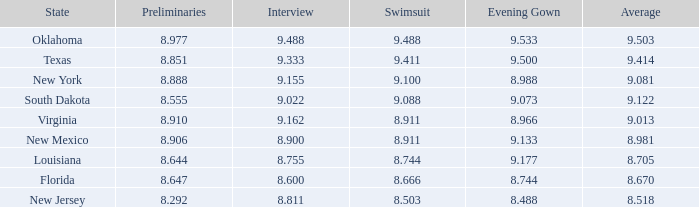What are the preliminaries in the state of south dakota? 8.555. 